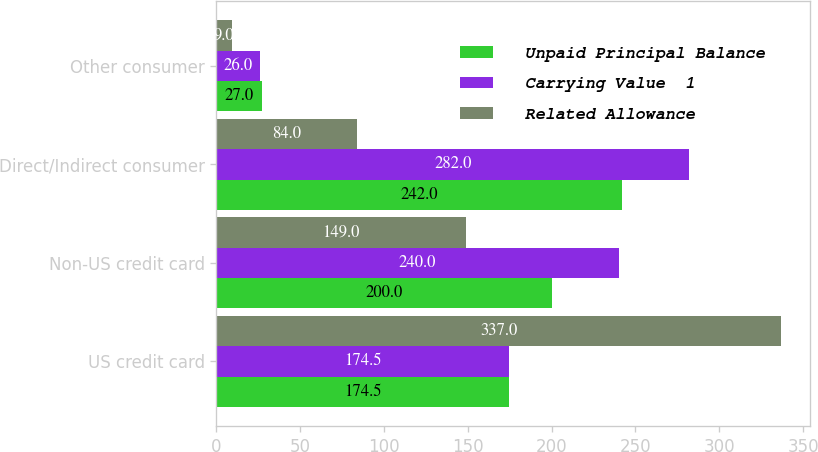Convert chart. <chart><loc_0><loc_0><loc_500><loc_500><stacked_bar_chart><ecel><fcel>US credit card<fcel>Non-US credit card<fcel>Direct/Indirect consumer<fcel>Other consumer<nl><fcel>Unpaid Principal Balance<fcel>174.5<fcel>200<fcel>242<fcel>27<nl><fcel>Carrying Value  1<fcel>174.5<fcel>240<fcel>282<fcel>26<nl><fcel>Related Allowance<fcel>337<fcel>149<fcel>84<fcel>9<nl></chart> 